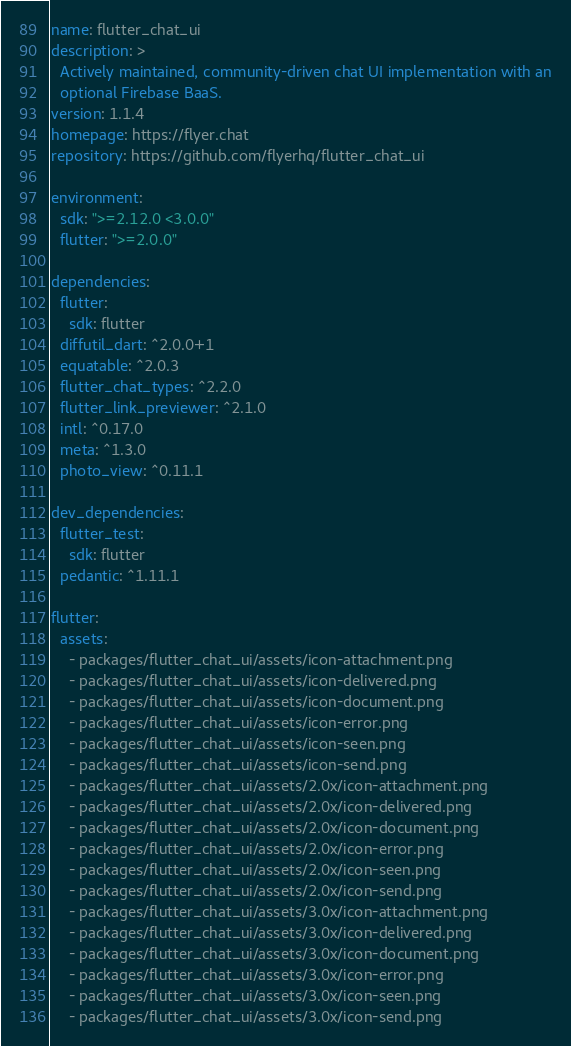<code> <loc_0><loc_0><loc_500><loc_500><_YAML_>name: flutter_chat_ui
description: >
  Actively maintained, community-driven chat UI implementation with an
  optional Firebase BaaS.
version: 1.1.4
homepage: https://flyer.chat
repository: https://github.com/flyerhq/flutter_chat_ui

environment:
  sdk: ">=2.12.0 <3.0.0"
  flutter: ">=2.0.0"

dependencies:
  flutter:
    sdk: flutter
  diffutil_dart: ^2.0.0+1
  equatable: ^2.0.3
  flutter_chat_types: ^2.2.0
  flutter_link_previewer: ^2.1.0
  intl: ^0.17.0
  meta: ^1.3.0
  photo_view: ^0.11.1

dev_dependencies:
  flutter_test:
    sdk: flutter
  pedantic: ^1.11.1

flutter:
  assets:
    - packages/flutter_chat_ui/assets/icon-attachment.png
    - packages/flutter_chat_ui/assets/icon-delivered.png
    - packages/flutter_chat_ui/assets/icon-document.png
    - packages/flutter_chat_ui/assets/icon-error.png
    - packages/flutter_chat_ui/assets/icon-seen.png
    - packages/flutter_chat_ui/assets/icon-send.png
    - packages/flutter_chat_ui/assets/2.0x/icon-attachment.png
    - packages/flutter_chat_ui/assets/2.0x/icon-delivered.png
    - packages/flutter_chat_ui/assets/2.0x/icon-document.png
    - packages/flutter_chat_ui/assets/2.0x/icon-error.png
    - packages/flutter_chat_ui/assets/2.0x/icon-seen.png
    - packages/flutter_chat_ui/assets/2.0x/icon-send.png
    - packages/flutter_chat_ui/assets/3.0x/icon-attachment.png
    - packages/flutter_chat_ui/assets/3.0x/icon-delivered.png
    - packages/flutter_chat_ui/assets/3.0x/icon-document.png
    - packages/flutter_chat_ui/assets/3.0x/icon-error.png
    - packages/flutter_chat_ui/assets/3.0x/icon-seen.png
    - packages/flutter_chat_ui/assets/3.0x/icon-send.png
</code> 